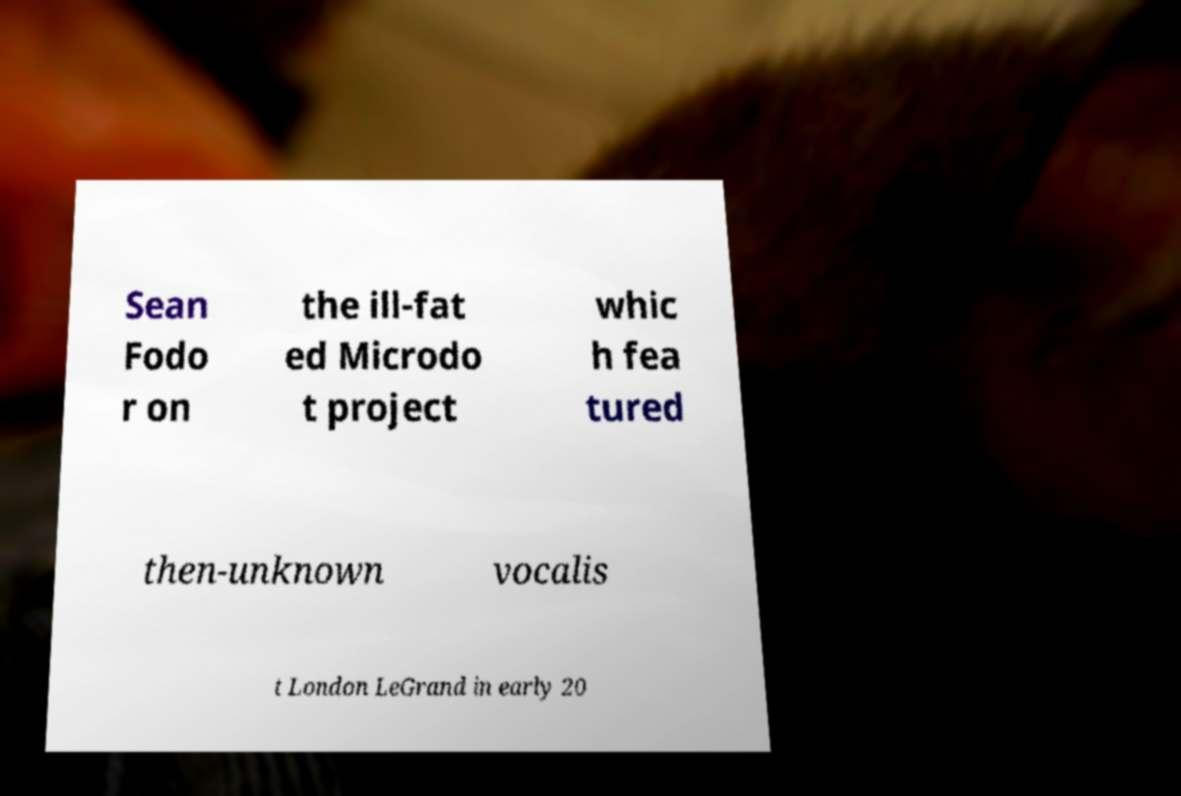Can you read and provide the text displayed in the image?This photo seems to have some interesting text. Can you extract and type it out for me? Sean Fodo r on the ill-fat ed Microdo t project whic h fea tured then-unknown vocalis t London LeGrand in early 20 